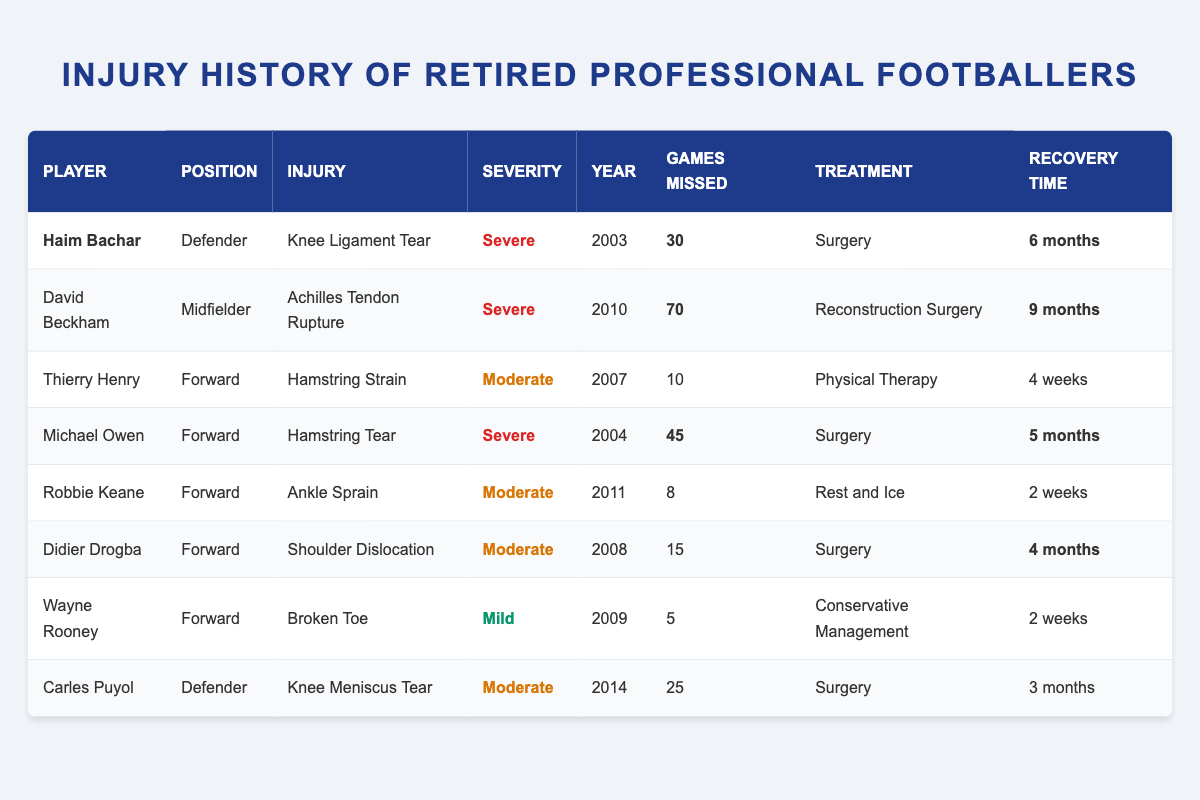What injury did Haim Bachar suffer? The table lists Haim Bachar's injury as "Knee Ligament Tear" in the Injury column.
Answer: Knee Ligament Tear How many games did David Beckham miss due to his injury? The table shows that David Beckham missed a total of 70 games as indicated in the Games Missed column.
Answer: 70 What was the recovery time for Michael Owen's injury? According to the table, Michael Owen's recovery time is noted as "5 months" in the Recovery Time column.
Answer: 5 months Which player experienced an injury in 2011? By examining the Year Injured column, Robbie Keane is the player listed with an injury in 2011.
Answer: Robbie Keane Was Wayne Rooney's injury considered severe? The Injury Severity column indicates Wayne Rooney's injury as "Mild," suggesting it was not severe.
Answer: No How many total games were missed by players with severe injuries? The severe injuries include Haim Bachar (30), David Beckham (70), and Michael Owen (45). Adding these gives 30 + 70 + 45 = 145.
Answer: 145 Which position had the most incidents of moderate injuries? In the moderate injury category, the positions listed are Defender (Carles Puyol), Forward (Didier Drogba, Thierry Henry, Robbie Keane). There are 3 forwards and 1 defender with moderate injuries, making forwards the most represented position.
Answer: Forward What is the average recovery time for players who had mild injuries? The only player with a mild injury is Wayne Rooney, with a recovery time of "2 weeks." Thus, the average is 2 weeks since there's only one data point.
Answer: 2 weeks Which player had the longest recovery time and what was it? By checking the Recovery Time column, David Beckham had the longest recovery time of "9 months."
Answer: 9 months Which injury caused the highest number of games missed among all players? Looking at the Games Missed column, David Beckham missed 70 games, which is the highest among all players listed.
Answer: 70 